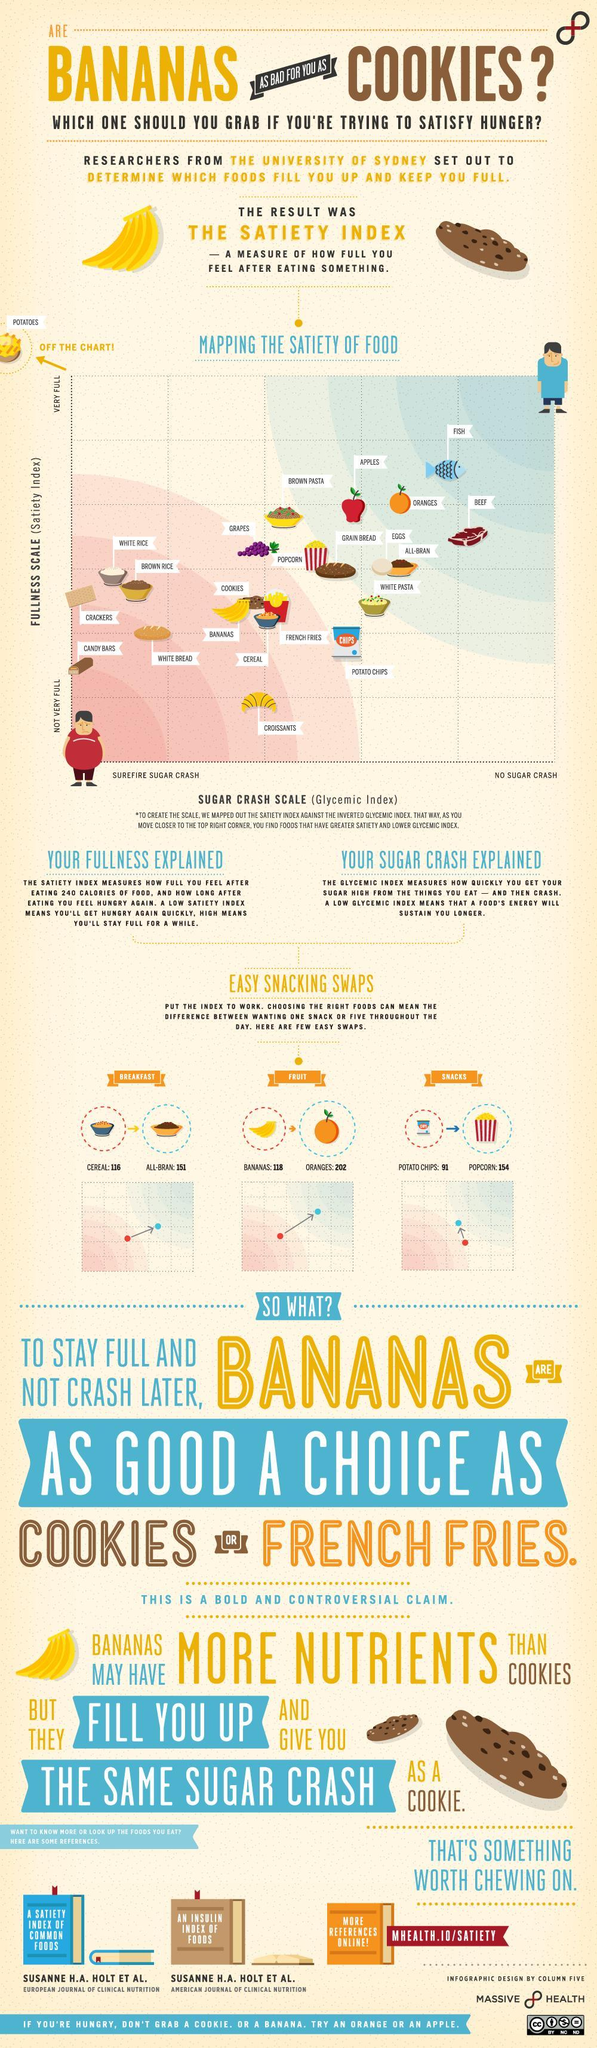What should bananas be swapped with cereal, all-bran, or oranges?
Answer the question with a short phrase. oranges What should potato crisps be swapped with bananas, popcorn, or oranges? popcorn Which food has the highest satiety and the lowest sugar crash scale? Fish Which other foods have the same sugar crash scale similar to bananas? Cookies, French Fries, Cereal What should one have instead of cereal, bananas, popcorn, or all-bran? all-bran Which food has the lowest satiety and the highest sugar crash scale? Candy Bars 